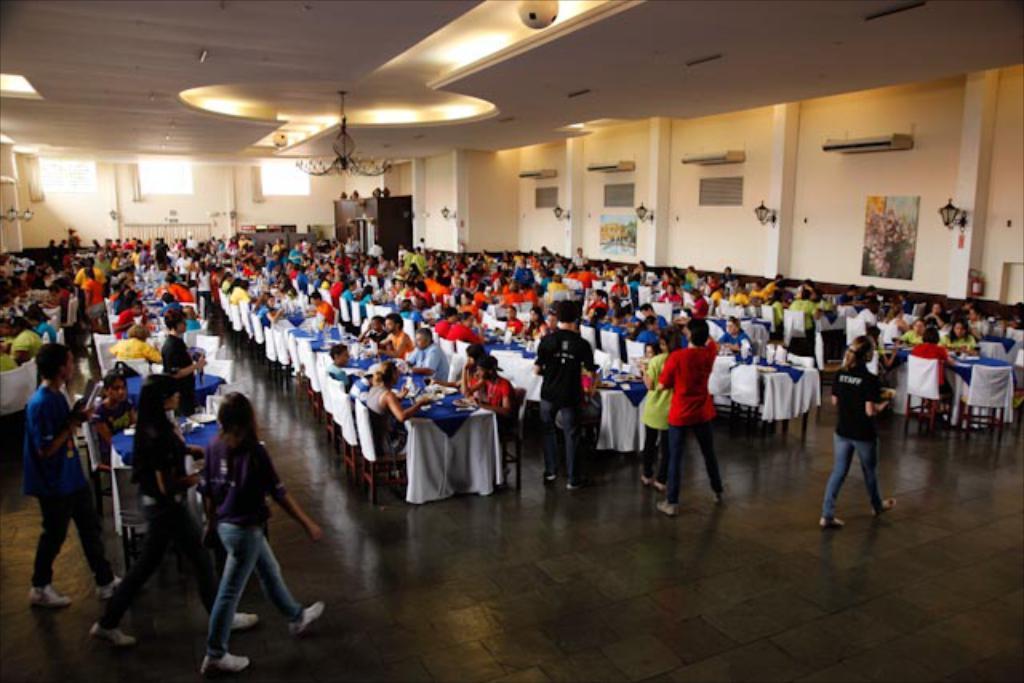Describe this image in one or two sentences. In this image we can see many persons sitting on the chairs at the table. On the table we can see plates, food, water bottles, glass tumblers. At the bottom of the image we can see persons walking. In the background we can see persons, windows, lights and wall. 